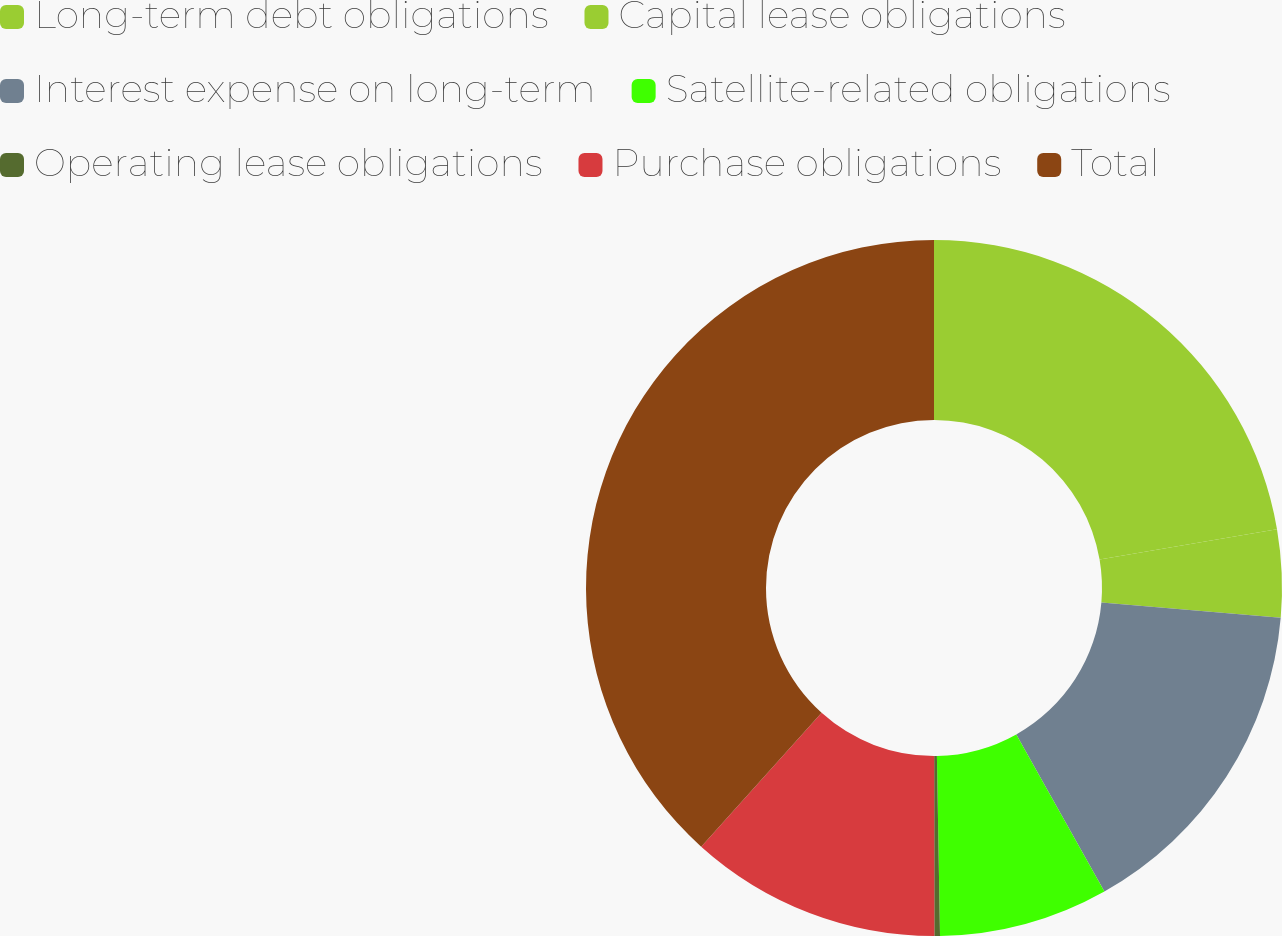Convert chart to OTSL. <chart><loc_0><loc_0><loc_500><loc_500><pie_chart><fcel>Long-term debt obligations<fcel>Capital lease obligations<fcel>Interest expense on long-term<fcel>Satellite-related obligations<fcel>Operating lease obligations<fcel>Purchase obligations<fcel>Total<nl><fcel>22.3%<fcel>4.07%<fcel>15.49%<fcel>7.87%<fcel>0.26%<fcel>11.68%<fcel>38.34%<nl></chart> 